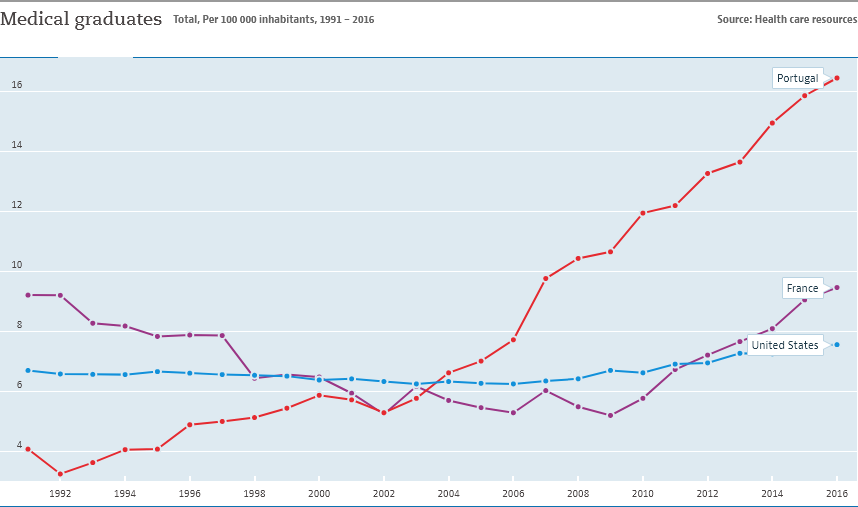Point out several critical features in this image. Portugal is represented by a red color line in the country. In 2016, the highest number of medical graduates was recorded in Portugal. 